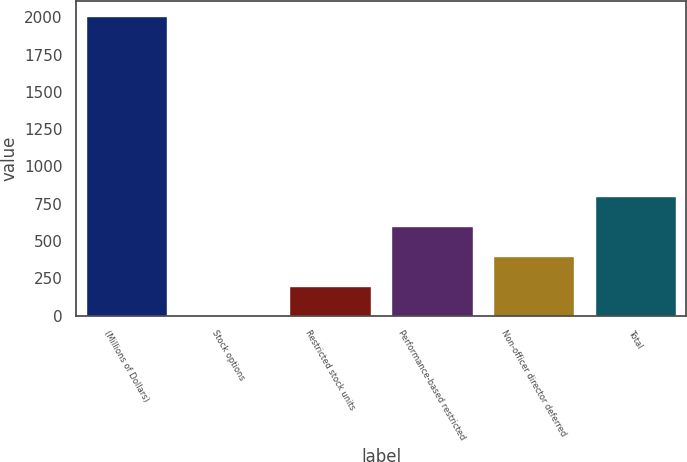Convert chart. <chart><loc_0><loc_0><loc_500><loc_500><bar_chart><fcel>(Millions of Dollars)<fcel>Stock options<fcel>Restricted stock units<fcel>Performance-based restricted<fcel>Non-officer director deferred<fcel>Total<nl><fcel>2007<fcel>1<fcel>201.6<fcel>602.8<fcel>402.2<fcel>803.4<nl></chart> 